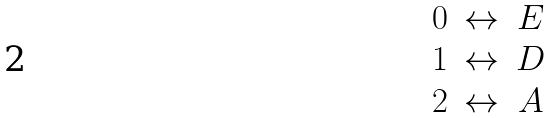Convert formula to latex. <formula><loc_0><loc_0><loc_500><loc_500>\begin{array} { c c c } 0 & \leftrightarrow & E \\ 1 & \leftrightarrow & D \\ 2 & \leftrightarrow & A \end{array}</formula> 